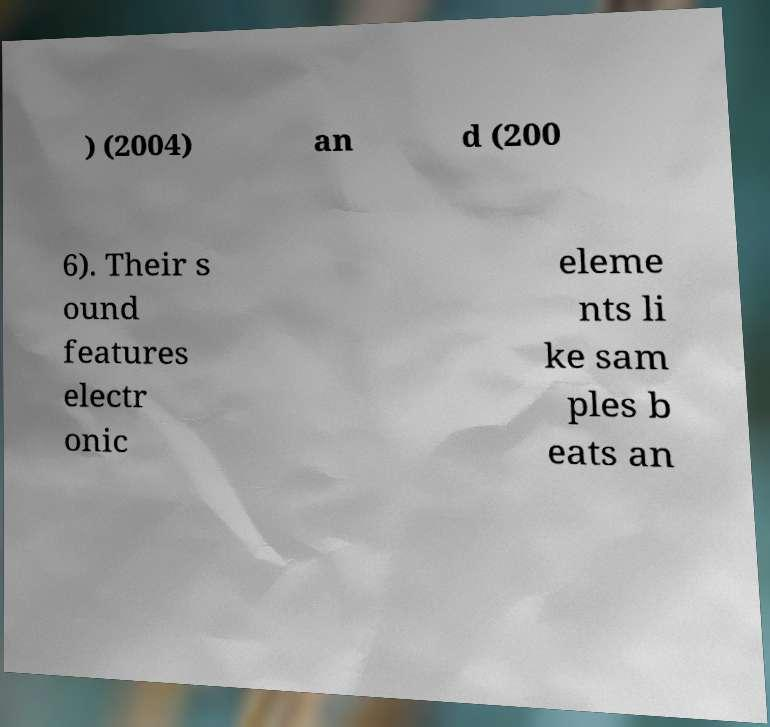For documentation purposes, I need the text within this image transcribed. Could you provide that? ) (2004) an d (200 6). Their s ound features electr onic eleme nts li ke sam ples b eats an 